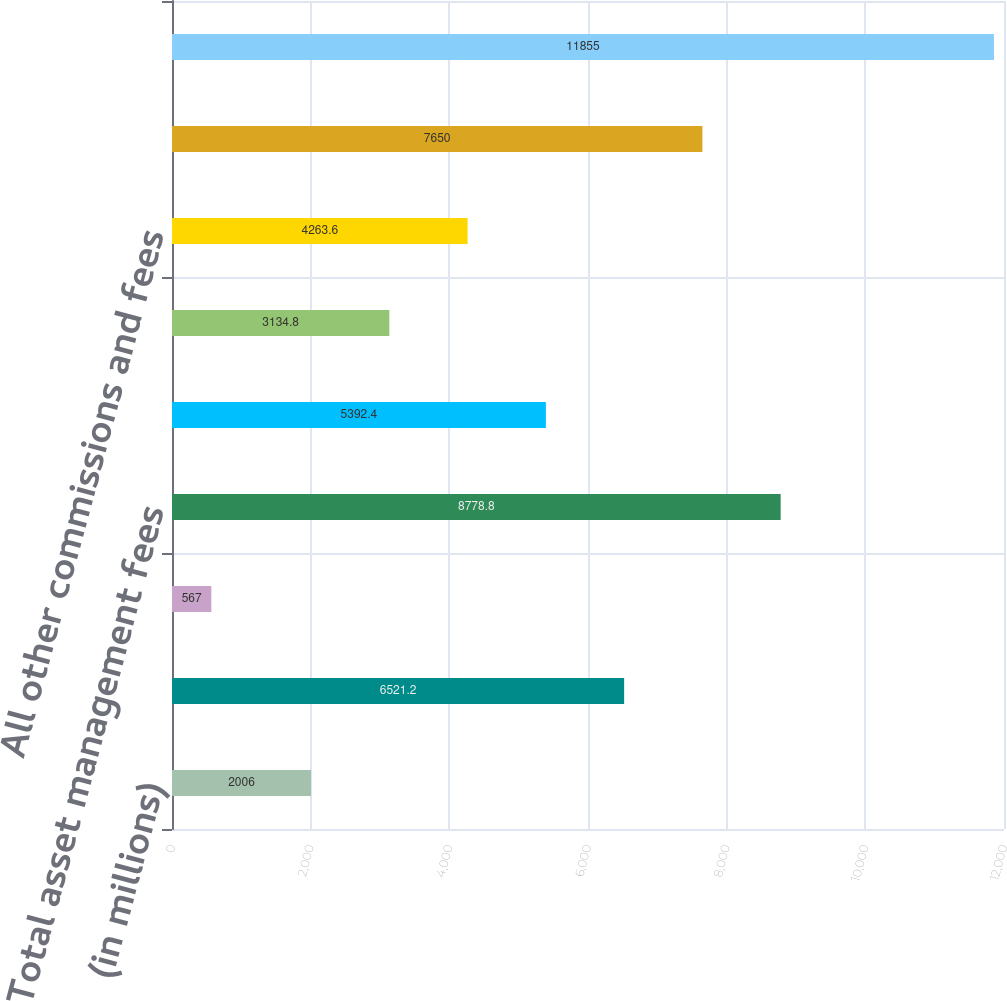Convert chart to OTSL. <chart><loc_0><loc_0><loc_500><loc_500><bar_chart><fcel>(in millions)<fcel>Investment management fees<fcel>All other asset management<fcel>Total asset management fees<fcel>Total administration fees (a)<fcel>Brokerage commissions<fcel>All other commissions and fees<fcel>Total commissions and fees<fcel>Total asset management<nl><fcel>2006<fcel>6521.2<fcel>567<fcel>8778.8<fcel>5392.4<fcel>3134.8<fcel>4263.6<fcel>7650<fcel>11855<nl></chart> 